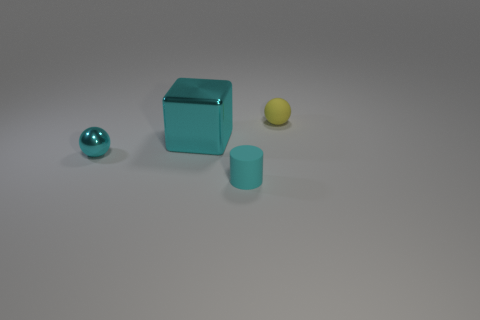What size is the matte object behind the large cyan metallic thing?
Make the answer very short. Small. The small cyan object in front of the small cyan object that is behind the small rubber cylinder is made of what material?
Offer a terse response. Rubber. What number of metallic objects are left of the thing on the right side of the tiny rubber thing that is in front of the small yellow rubber object?
Provide a short and direct response. 2. Is the tiny cyan thing that is in front of the cyan sphere made of the same material as the tiny sphere to the left of the large cyan metal cube?
Give a very brief answer. No. What material is the large thing that is the same color as the tiny cylinder?
Offer a terse response. Metal. What number of yellow matte objects are the same shape as the small shiny thing?
Offer a very short reply. 1. Are there more metallic spheres that are behind the small yellow object than large brown rubber cylinders?
Offer a very short reply. No. There is a cyan object on the left side of the big block in front of the tiny matte object behind the big cyan block; what shape is it?
Your answer should be compact. Sphere. There is a small matte object on the right side of the small cylinder; does it have the same shape as the small cyan object that is to the left of the large object?
Ensure brevity in your answer.  Yes. Are there any other things that have the same size as the cyan ball?
Offer a very short reply. Yes. 